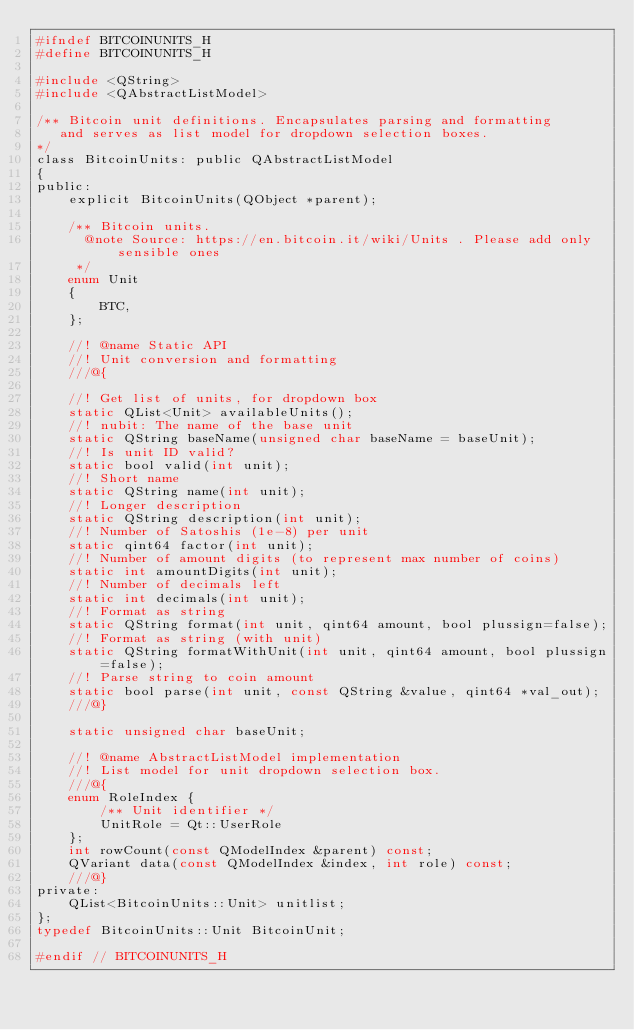Convert code to text. <code><loc_0><loc_0><loc_500><loc_500><_C_>#ifndef BITCOINUNITS_H
#define BITCOINUNITS_H

#include <QString>
#include <QAbstractListModel>

/** Bitcoin unit definitions. Encapsulates parsing and formatting
   and serves as list model for dropdown selection boxes.
*/
class BitcoinUnits: public QAbstractListModel
{
public:
    explicit BitcoinUnits(QObject *parent);

    /** Bitcoin units.
      @note Source: https://en.bitcoin.it/wiki/Units . Please add only sensible ones
     */
    enum Unit
    {
        BTC,
    };

    //! @name Static API
    //! Unit conversion and formatting
    ///@{

    //! Get list of units, for dropdown box
    static QList<Unit> availableUnits();
    //! nubit: The name of the base unit
    static QString baseName(unsigned char baseName = baseUnit);
    //! Is unit ID valid?
    static bool valid(int unit);
    //! Short name
    static QString name(int unit);
    //! Longer description
    static QString description(int unit);
    //! Number of Satoshis (1e-8) per unit
    static qint64 factor(int unit);
    //! Number of amount digits (to represent max number of coins)
    static int amountDigits(int unit);
    //! Number of decimals left
    static int decimals(int unit);
    //! Format as string
    static QString format(int unit, qint64 amount, bool plussign=false);
    //! Format as string (with unit)
    static QString formatWithUnit(int unit, qint64 amount, bool plussign=false);
    //! Parse string to coin amount
    static bool parse(int unit, const QString &value, qint64 *val_out);
    ///@}

    static unsigned char baseUnit;

    //! @name AbstractListModel implementation
    //! List model for unit dropdown selection box.
    ///@{
    enum RoleIndex {
        /** Unit identifier */
        UnitRole = Qt::UserRole
    };
    int rowCount(const QModelIndex &parent) const;
    QVariant data(const QModelIndex &index, int role) const;
    ///@}
private:
    QList<BitcoinUnits::Unit> unitlist;
};
typedef BitcoinUnits::Unit BitcoinUnit;

#endif // BITCOINUNITS_H
</code> 